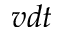Convert formula to latex. <formula><loc_0><loc_0><loc_500><loc_500>v d t</formula> 